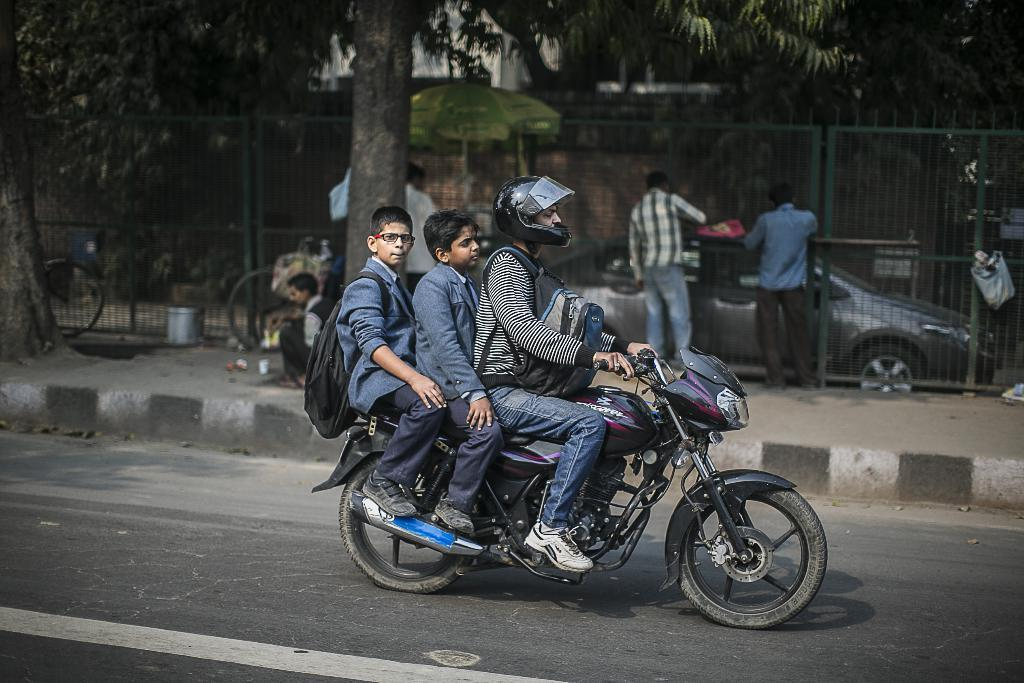How many people are riding the bike in the image? There are three people sitting on the same bike in the image. What are the people on the bike doing? The people are traveling. Can you describe the surroundings in the image? There are many people around, a car, a tree, a tent, iron fencing, and a road in the image. What color is the beef in the image? There is no beef present in the image. How do the people on the bike maintain their grip while traveling? The image does not provide information about how the people on the bike maintain their grip, but it is likely that they are holding onto the bike's handlebars or frame. 